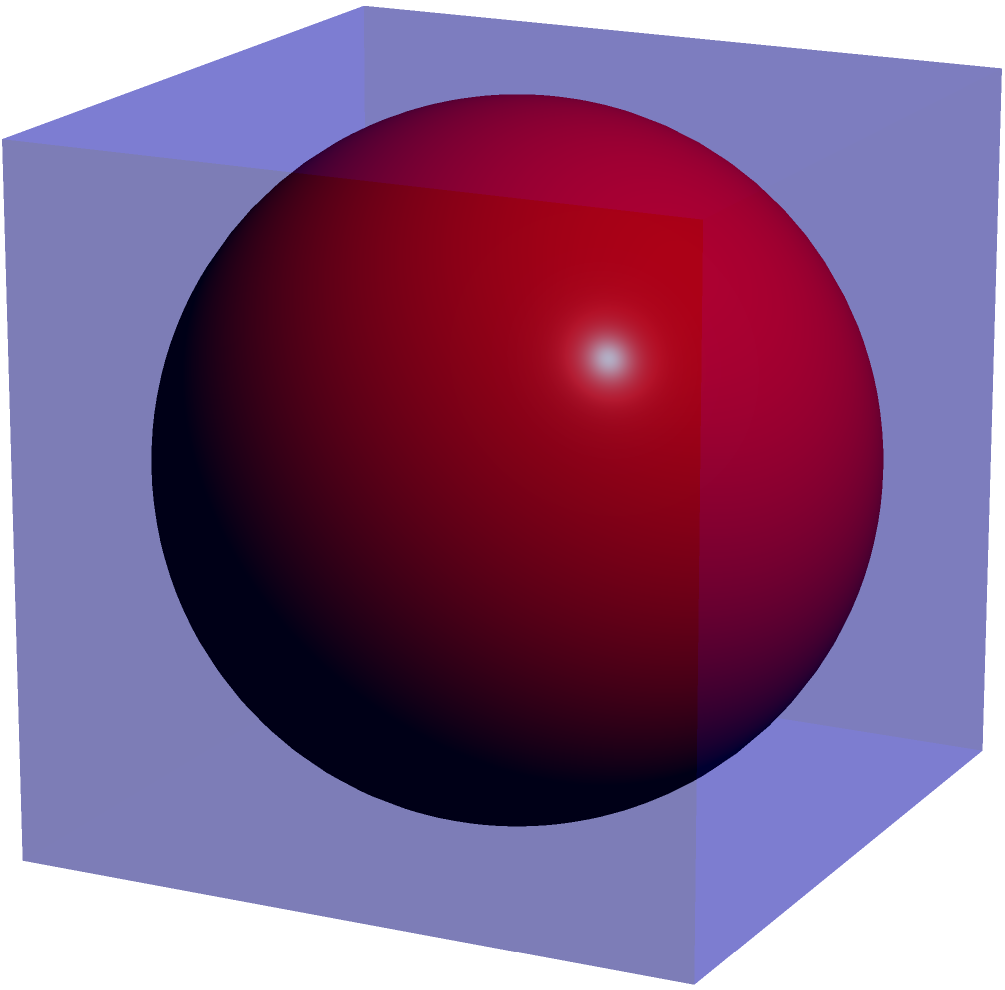In a literary analysis of spatial metaphors in the poet laureate's work, you encounter a recurring image of a sphere contained within a cube. If the edge length of the cube is 6 units, what is the volume of the inscribed sphere? Express your answer in terms of π. Let's approach this step-by-step:

1) First, recall that the diameter of an inscribed sphere is equal to the edge length of the cube. This is because the sphere touches the cube at the center of each face.

2) Given that the edge length of the cube is 6 units, the diameter of the sphere is also 6 units.

3) The radius of the sphere is half of its diameter. So, the radius $r = 6/2 = 3$ units.

4) The formula for the volume of a sphere is:

   $$V = \frac{4}{3}\pi r^3$$

5) Substituting our radius value:

   $$V = \frac{4}{3}\pi (3)^3$$

6) Simplify:
   
   $$V = \frac{4}{3}\pi (27) = 36\pi$$

Therefore, the volume of the inscribed sphere is $36\pi$ cubic units.
Answer: $36\pi$ cubic units 